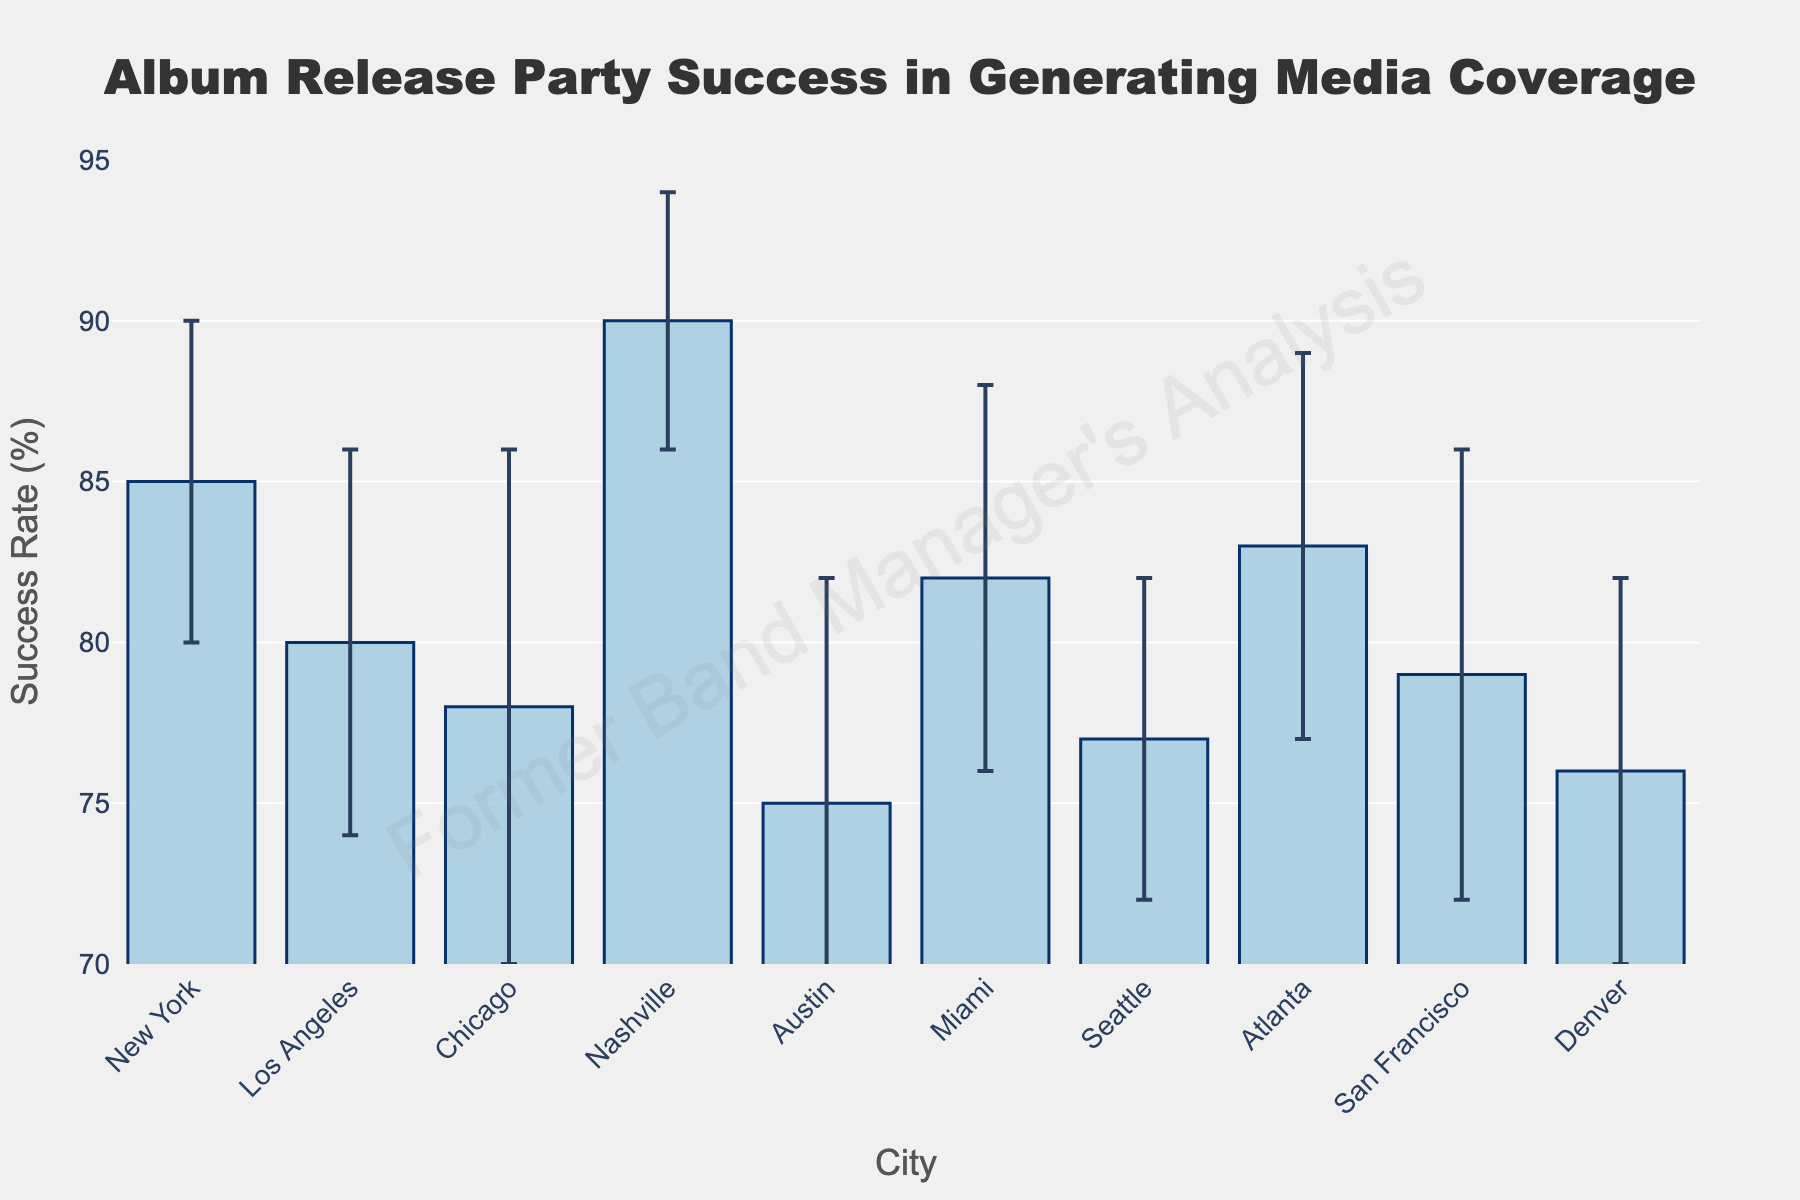what is the title of the figure? The title is displayed at the top of the figure. It reads "Album Release Party Success in Generating Media Coverage".
Answer: Album Release Party Success in Generating Media Coverage Which city has the highest success rate in generating media coverage? The success rates are shown as bars for each city. The tallest bar represents Nashville, with a success rate of 90%.
Answer: Nashville How many cities have a success rate of 80% or higher? By looking at the height of the bars, count the cities where the bar reaches or exceeds the 80% mark. The cities are New York, Los Angeles, Nashville, Miami, and Atlanta, for a total of 5 cities.
Answer: 5 What's the difference between the highest and lowest success rates? The highest success rate is for Nashville (90%), and the lowest is for Austin (75%). Subtract the lowest from the highest: 90 - 75 = 15.
Answer: 15 What are the error bars used to represent in this figure? The error bars visually indicate the variability of the media coverage success rate across different cities. They show how much the success rate can vary.
Answer: Variability of coverage Which city has the largest error bar? Check the error bars for each city. Chicago has the largest error bar, which is 8%.
Answer: Chicago Which cities have a success rate between 75% and 80%, inclusive? Identify the cities whose bars fall within or touch the 75% to 80% range. The cities are Austin, Seattle, San Francisco, and Denver.
Answer: Austin, Seattle, San Francisco, Denver How does the success rate of Los Angeles compare to that of Chicago? Los Angeles has a success rate of 80%, while Chicago has a success rate of 78%. Los Angeles has a higher success rate by 2%.
Answer: Los Angeles has a higher success rate by 2% What is the average success rate for the cities shown? Add the success rates for all cities shown: 85 (NY) + 80 (LA) + 78 (Chicago) + 90 (Nashville) + 75 (Austin) + 82 (Miami) + 77 (Seattle) + 83 (Atlanta) + 79 (San Francisco) + 76 (Denver) = 805. Divide by the number of cities (10): 805/10 = 80.5.
Answer: 80.5 Which cities have error bars that indicate a possible success rate lower than 75%? Calculate the lower bounds of the error bars for each city. Only Austin, with a success rate of 75% and an error bar of 7%, can potentially have a success rate as low as 68%.
Answer: Austin 